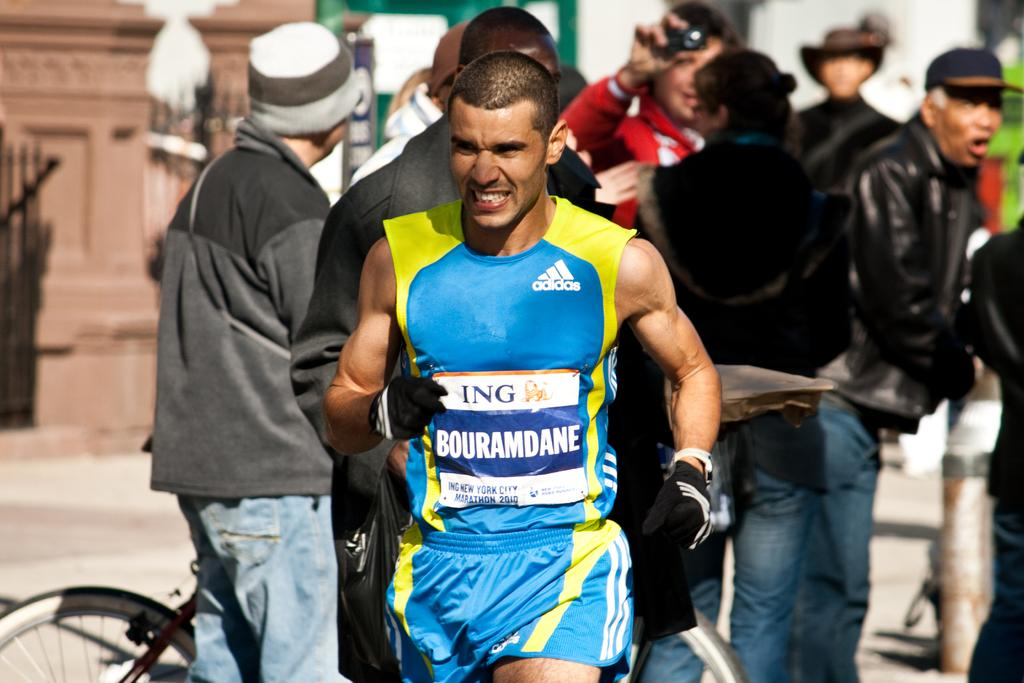<image>
Present a compact description of the photo's key features. Man wearing a shirt with a sign that says "Bouramdane" on it. 